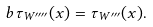Convert formula to latex. <formula><loc_0><loc_0><loc_500><loc_500>b \tau _ { W ^ { \prime \prime \prime \prime } } ( x ) = \tau _ { W ^ { \prime \prime \prime } } ( x ) .</formula> 